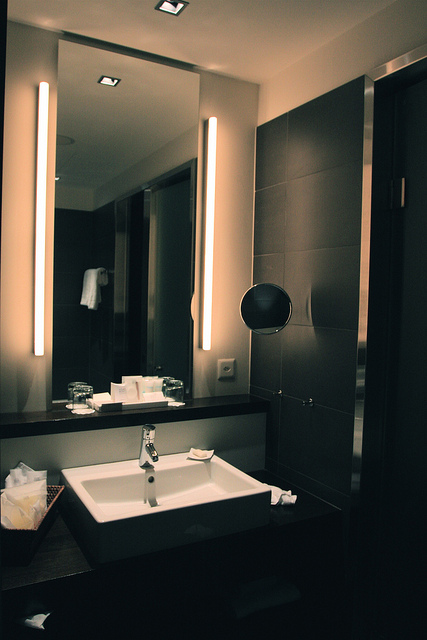Based on the objects and their placements, what can you infer about the design or purpose of this bathroom? The bathroom appears to be modern and upscale, emphasizing both functionality and aesthetics. The clean lines, sleek fixtures, and the presence of multiple soap dispensers, as well as large mirrors with illuminated light fixtures, indicate a design meant for comfort and utility. This setting suggests a place that prioritizes convenience and could be used by multiple users, possibly in a high-end residential or hotel environment. 